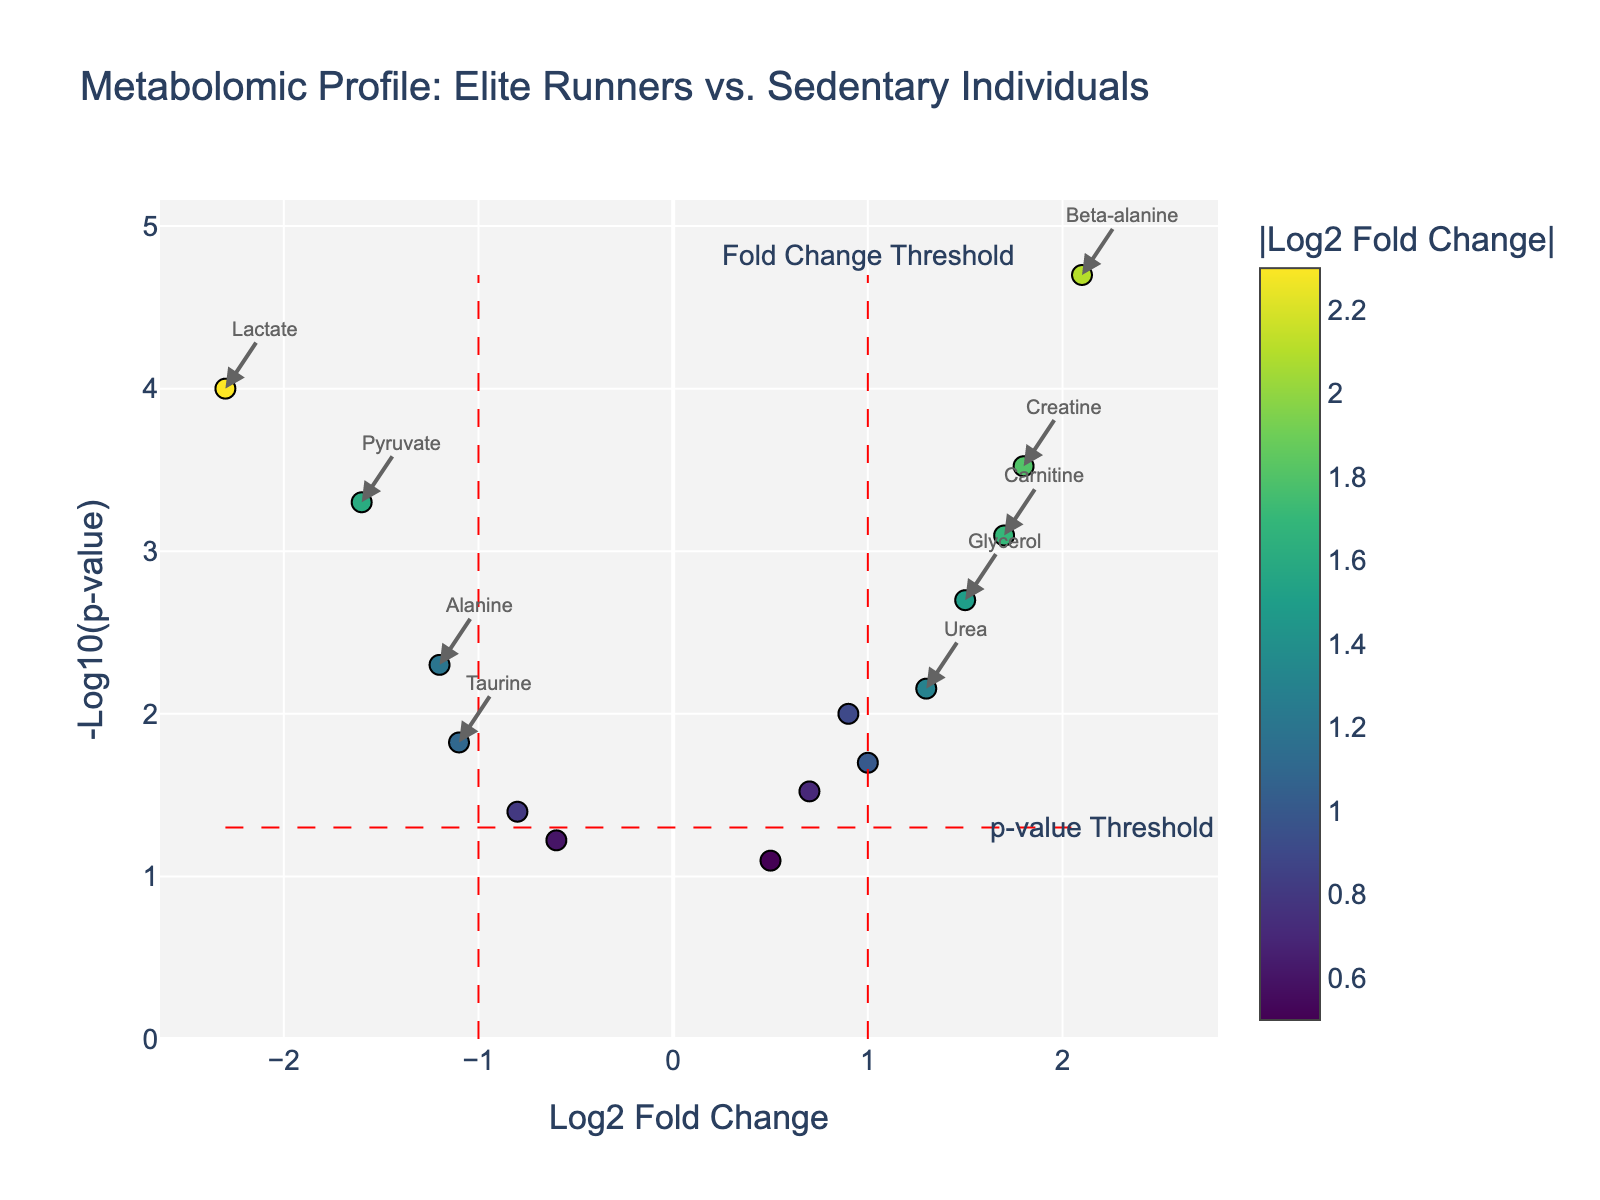What's the title of this figure? The title is displayed at the top of the plot.
Answer: Metabolomic Profile: Elite Runners vs. Sedentary Individuals Which metabolite has the smallest p-value? The smallest p-value can be identified by finding the highest -log10(p-value) on the y-axis. Beta-alanine stands out because its label is shown and it is far above the p-value threshold.
Answer: Beta-alanine What is the log2 fold change of Lactate and is it upregulated or downregulated? Locate the Lactate data point on the plot and check the x-axis value. It is at -2.3, meaning it is downregulated.
Answer: -2.3, downregulated How many metabolites have a log2 fold change greater than 1? Examine the plot and count the points that lie to the right of the x-axis value of 1.
Answer: 4 Which metabolite has the highest log2 fold change? Identify the data point farthest to the right on the x-axis; its label is Beta-alanine.
Answer: Beta-alanine How many metabolites are upregulated and statistically significant? Look for points that are to the right of the log2 fold change threshold (1) and above the p-value threshold (0.05). Count these points.
Answer: 3 Compare the log2 fold change values of Creatine and Carnitine. Which one is higher? Locate the two metabolites on the plot, and check their positions on the x-axis. Carnitine is at 1.7 and Creatine is at 1.8; thus, Creatine is higher.
Answer: Creatine What is the p-value threshold shown on the plot? Find the red dashed horizontal line and read the y-axis value it corresponds to. It aligns with 0.05 on the p-value scale.
Answer: 0.05 Which metabolite is closer to the origin, Alanine or Citrate? Determine which of the two points (Alanine or Citrate) is nearest to (0,0) on the plot. Citrate is nearer, positioned at approximately (0.7, -log10(0.03)).
Answer: Citrate What is the log2 fold change of Pyruvate, and is it statistically significant? Check the label for Pyruvate and note its x-axis value (-1.6) and position above the horizontal significance line. It is statistically significant because its y-value is above the threshold.
Answer: -1.6, yes 